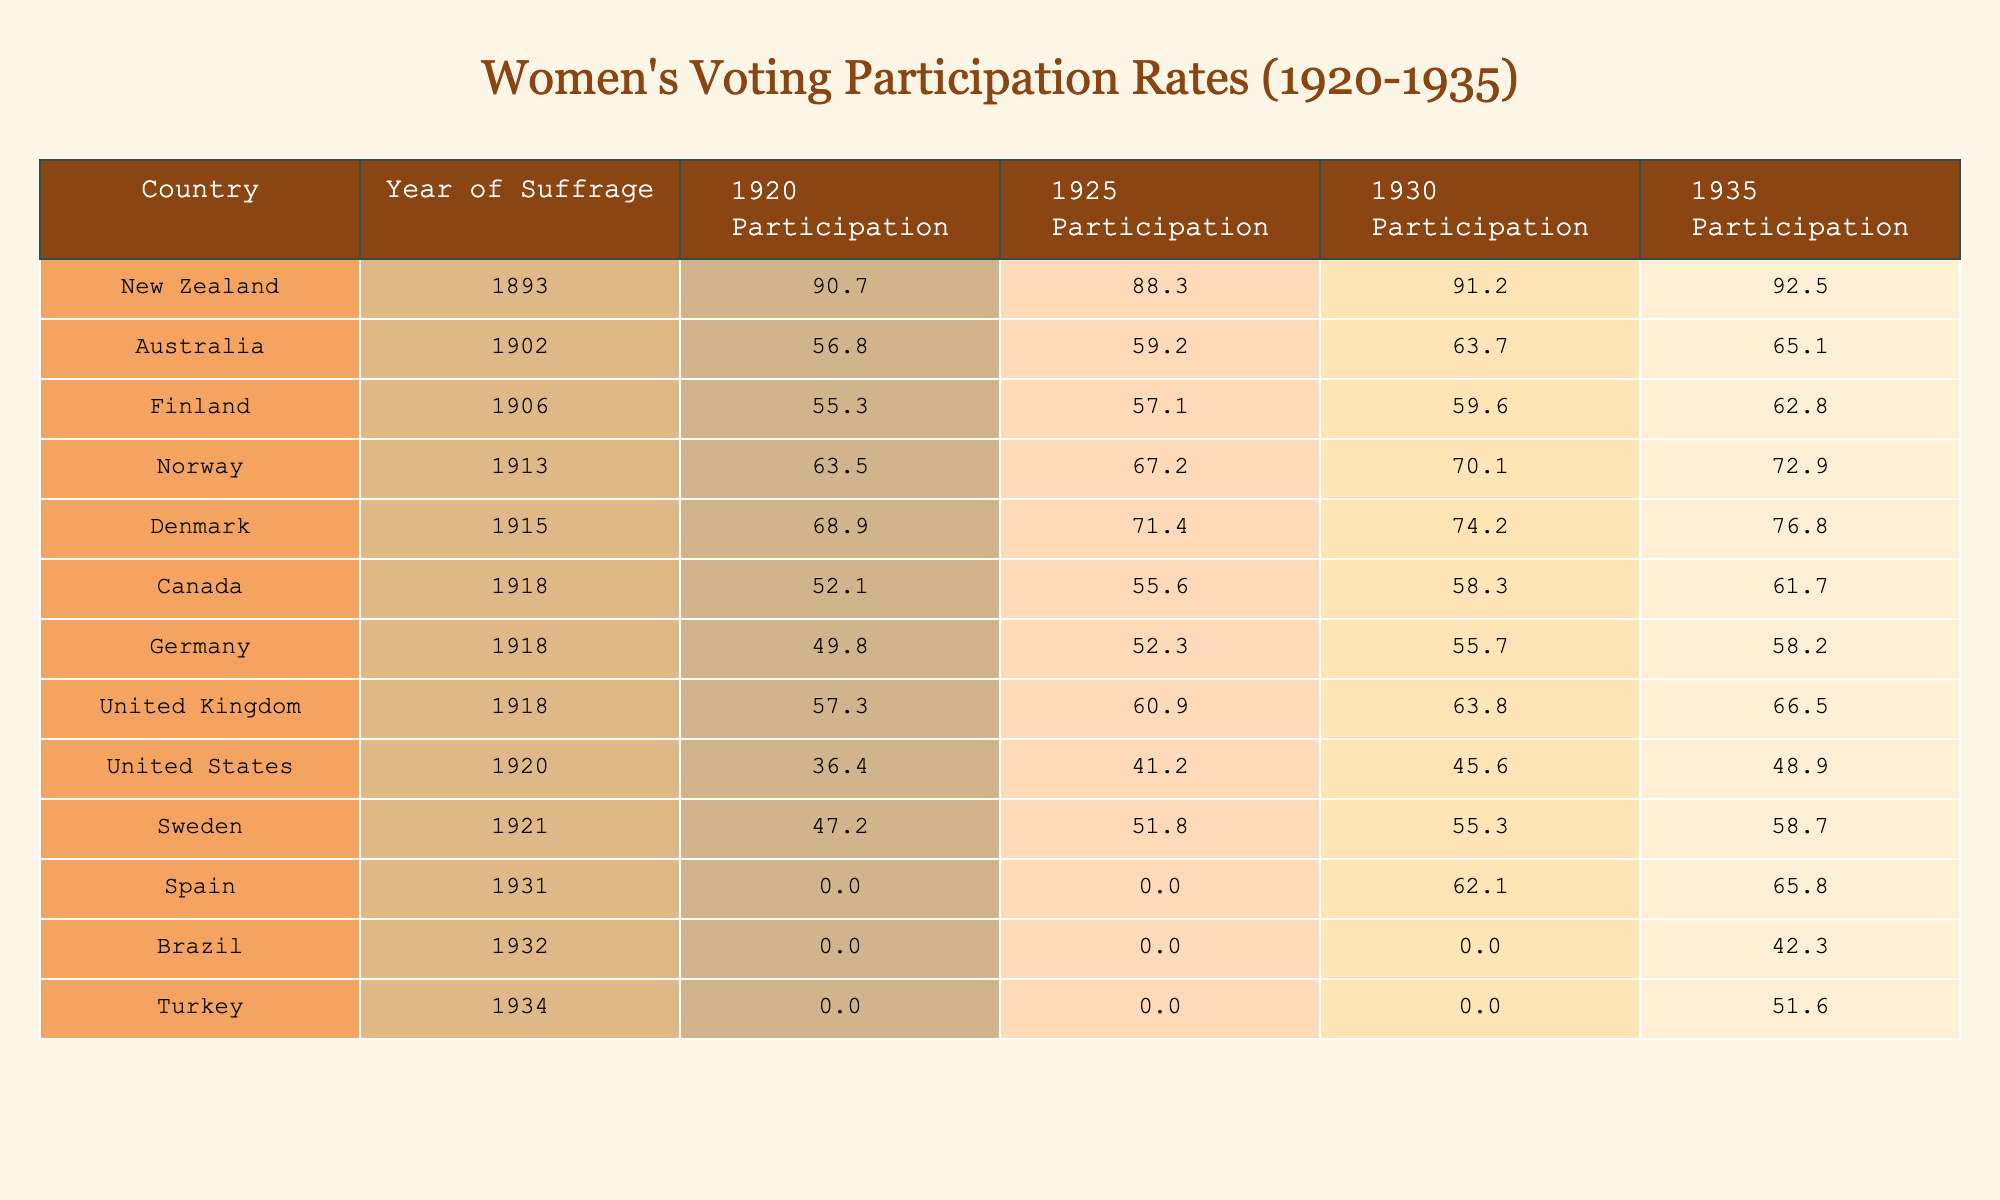Where did women first gain the right to vote? The table indicates that New Zealand was the first country to grant women suffrage in 1893.
Answer: New Zealand What was the women’s voting participation rate in Australia in 1935? According to the table, the participation rate in Australia in 1935 was 65.1%.
Answer: 65.1% Which country had the highest voting participation rate for women in 1920? By examining the table, New Zealand had the highest voting participation rate in 1920 at 90.7%.
Answer: 90.7% What was the average voting participation rate for women in Finland from 1920 to 1935? The participation rates for Finland are 55.3, 57.1, 59.6, and 62.8. Adding these gives 234.8, and dividing by 4 results in an average of 58.7%.
Answer: 58.7% Did women in Canada achieve a participation rate of over 60% by 1935? The table shows that the participation rate for Canada in 1935 was 61.7%, which is over 60%.
Answer: Yes What is the difference in voting participation rates for women in Germany from 1920 to 1935? In 1920 the rate was 49.8% and in 1935 it was 58.2%. The difference is 58.2 - 49.8 = 8.4%.
Answer: 8.4% In which year did the U.S. reach a participation rate closest to 50% for women? Looking at the table, the United States had a participation rate of 48.9% in 1935, which is the closest year to 50%.
Answer: 1935 Which country saw the largest increase in women’s voting participation from 1920 to 1935? By analyzing the rates, Norway increased from 63.5% in 1920 to 72.9% in 1935, a total increase of 9.4%. The calculation for the largest increase among all countries confirms this.
Answer: Norway What was the participation rate for women in Spain in 1930? The table indicates that the rate for Spain is missing (N/A) for 1930.
Answer: N/A How did women's voting participation in the U.S. change from 1920 to 1930? The participation rate dropped from 36.4% in 1920 to 45.6% in 1930, indicating an increase of 9.2%. The calculations confirm this change.
Answer: Increased by 9.2% 